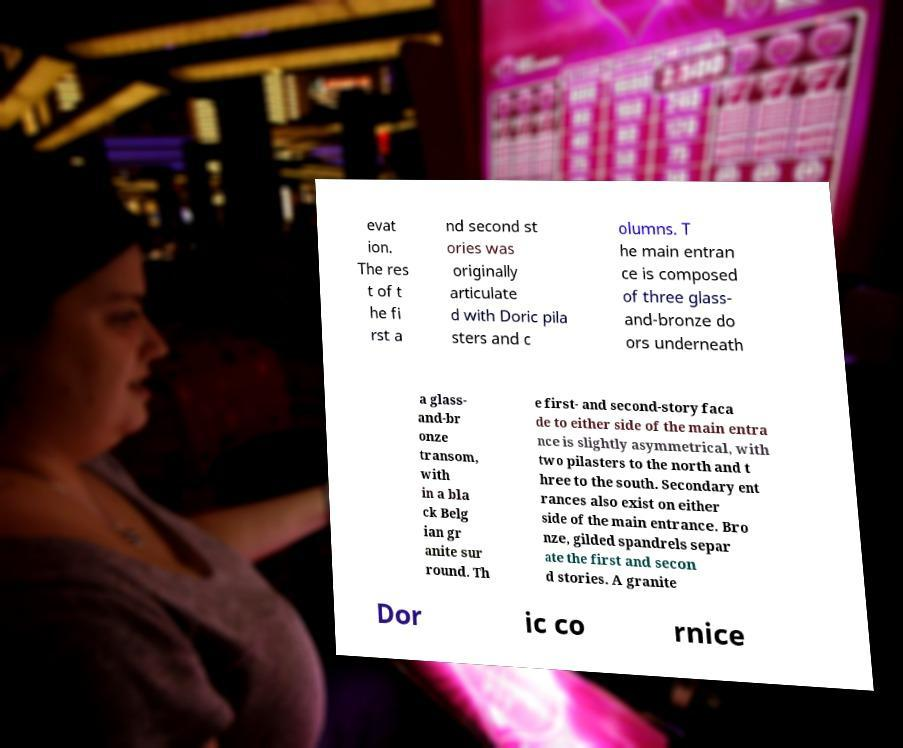Could you extract and type out the text from this image? evat ion. The res t of t he fi rst a nd second st ories was originally articulate d with Doric pila sters and c olumns. T he main entran ce is composed of three glass- and-bronze do ors underneath a glass- and-br onze transom, with in a bla ck Belg ian gr anite sur round. Th e first- and second-story faca de to either side of the main entra nce is slightly asymmetrical, with two pilasters to the north and t hree to the south. Secondary ent rances also exist on either side of the main entrance. Bro nze, gilded spandrels separ ate the first and secon d stories. A granite Dor ic co rnice 